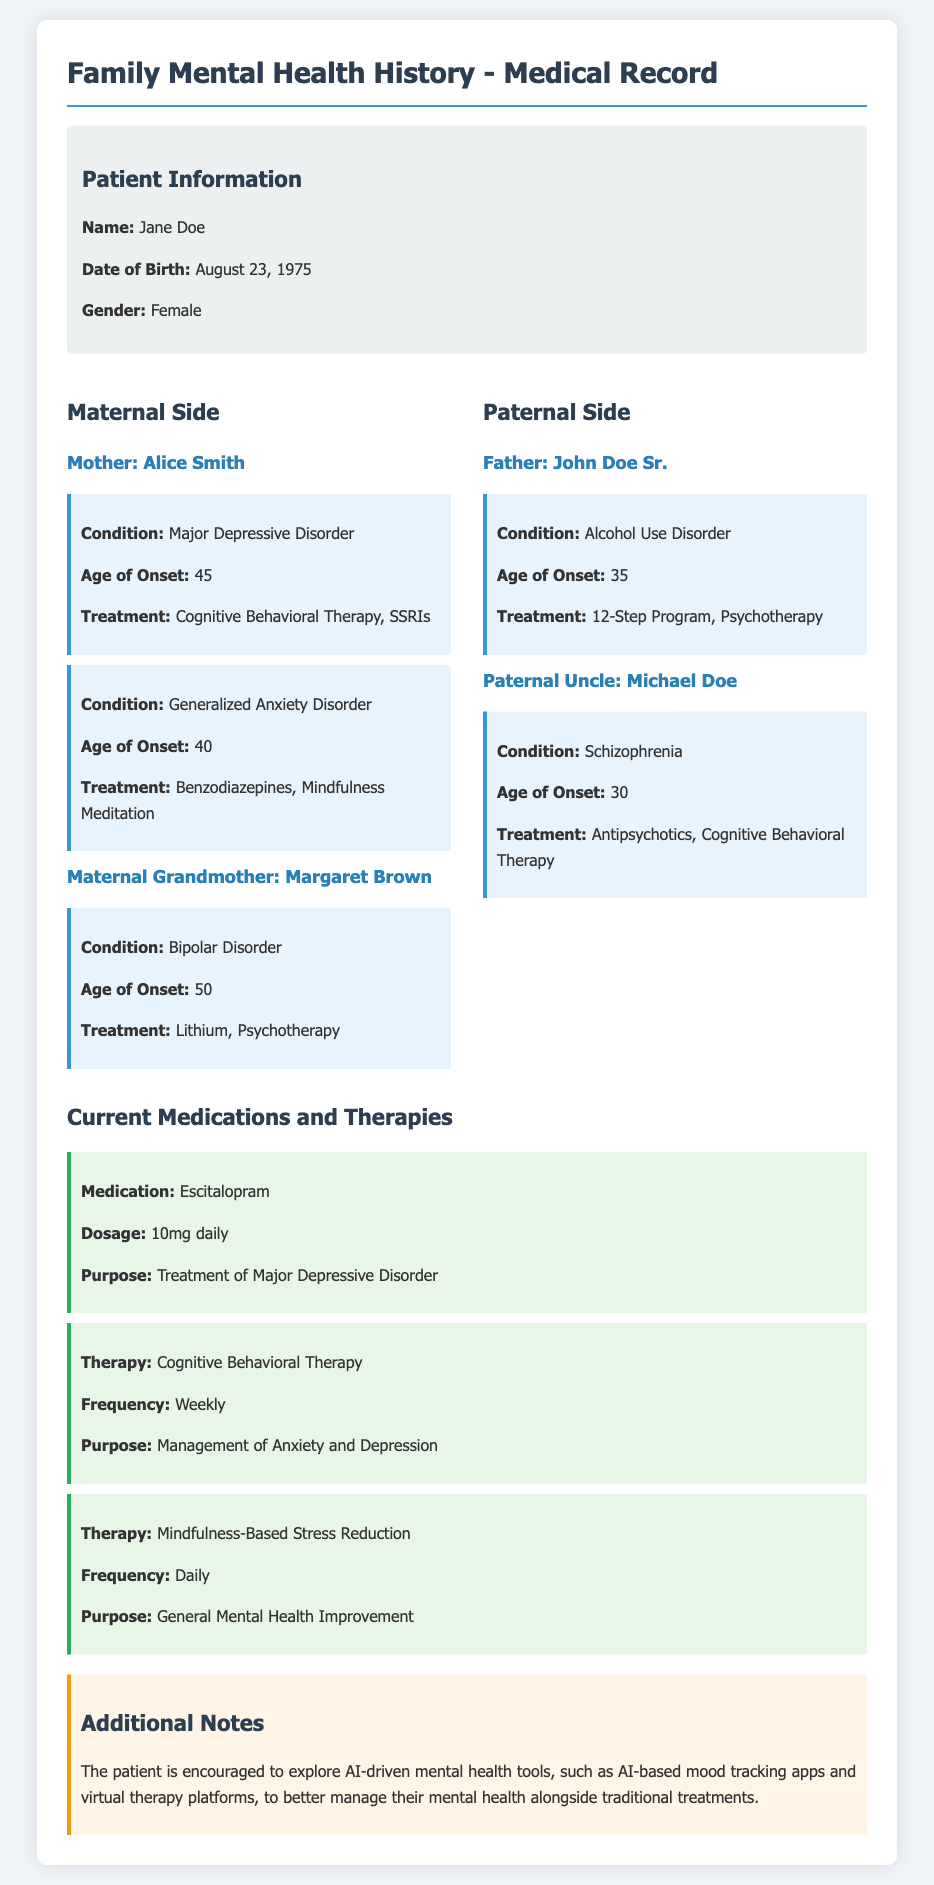What is the name of the patient? The patient's name is listed at the top of the document in the patient information section.
Answer: Jane Doe What is the date of birth of the patient's mother? The date of birth of the patient's mother is not explicitly stated, but her age of onset for her conditions can provide context.
Answer: 45 What condition did the patient's paternal uncle have? The document specifies the mental health condition of the patient's paternal uncle in the paternal family history section.
Answer: Schizophrenia What medication is the patient currently taking? The current medication section lists the specific medication prescribed to the patient.
Answer: Escitalopram What therapy does the patient practice weekly? The therapy section outlines different therapies the patient is undergoing, including frequency and purpose.
Answer: Cognitive Behavioral Therapy What age did the patient's father experience the onset of his condition? The document includes the age of onset for the father's condition in the paternal family history section.
Answer: 35 Which therapy is described as daily practice for the patient? The different therapies listed indicate how often each therapy is practiced by the patient.
Answer: Mindfulness-Based Stress Reduction What is the purpose of the medication taken by the patient? The purpose of the medication is specifically stated in the current medications section of the document.
Answer: Treatment of Major Depressive Disorder What additional tools are suggested for the patient to explore? Additional notes suggest various tools for managing mental health that are mentioned towards the end of the document.
Answer: AI-driven mental health tools 